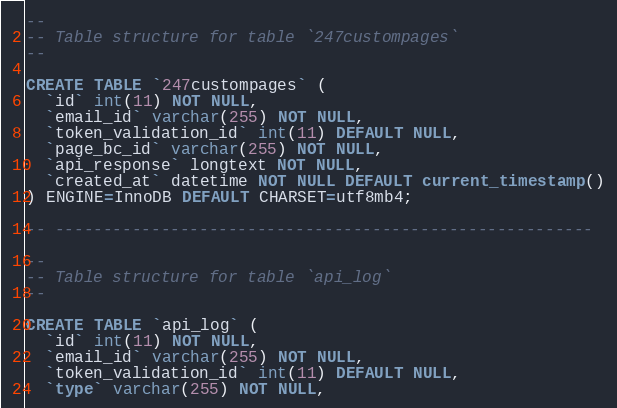Convert code to text. <code><loc_0><loc_0><loc_500><loc_500><_SQL_>
--
-- Table structure for table `247custompages`
--

CREATE TABLE `247custompages` (
  `id` int(11) NOT NULL,
  `email_id` varchar(255) NOT NULL,
  `token_validation_id` int(11) DEFAULT NULL,
  `page_bc_id` varchar(255) NOT NULL,
  `api_response` longtext NOT NULL,
  `created_at` datetime NOT NULL DEFAULT current_timestamp()
) ENGINE=InnoDB DEFAULT CHARSET=utf8mb4;

-- --------------------------------------------------------

--
-- Table structure for table `api_log`
--

CREATE TABLE `api_log` (
  `id` int(11) NOT NULL,
  `email_id` varchar(255) NOT NULL,
  `token_validation_id` int(11) DEFAULT NULL,
  `type` varchar(255) NOT NULL,</code> 